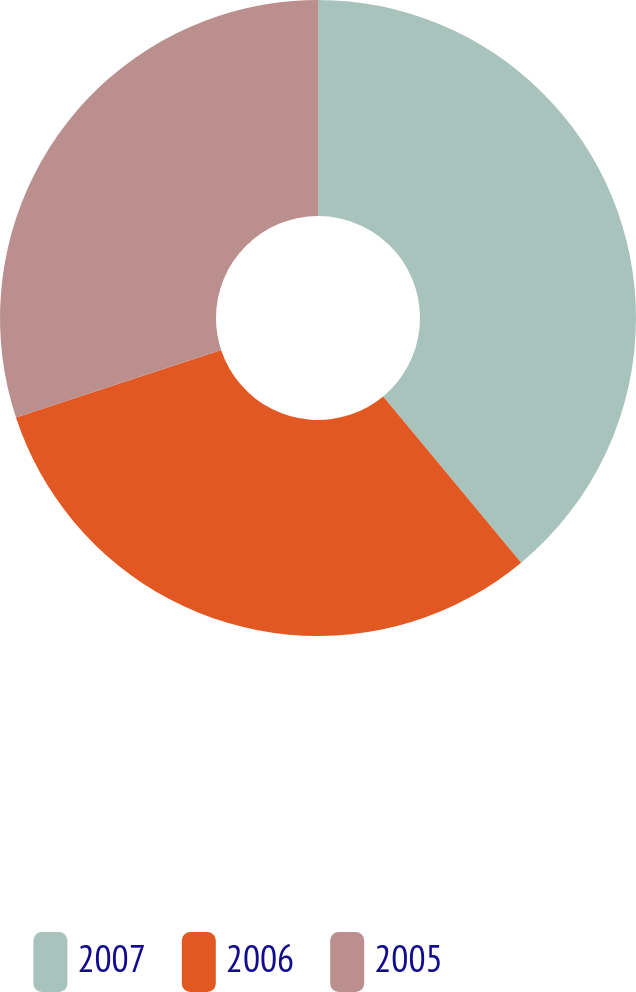<chart> <loc_0><loc_0><loc_500><loc_500><pie_chart><fcel>2007<fcel>2006<fcel>2005<nl><fcel>38.97%<fcel>30.96%<fcel>30.07%<nl></chart> 